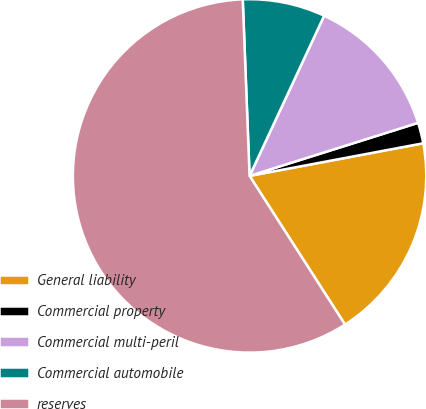Convert chart. <chart><loc_0><loc_0><loc_500><loc_500><pie_chart><fcel>General liability<fcel>Commercial property<fcel>Commercial multi-peril<fcel>Commercial automobile<fcel>reserves<nl><fcel>18.87%<fcel>1.9%<fcel>13.21%<fcel>7.55%<fcel>58.47%<nl></chart> 